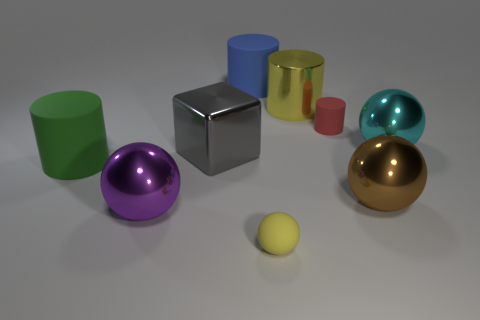There is a object that is the same color as the metal cylinder; what material is it?
Ensure brevity in your answer.  Rubber. Are there fewer purple metal objects that are behind the blue cylinder than shiny objects on the right side of the large gray metallic cube?
Give a very brief answer. Yes. What number of red cylinders are there?
Ensure brevity in your answer.  1. What is the color of the metallic sphere on the left side of the small yellow matte sphere?
Give a very brief answer. Purple. What size is the matte ball?
Your answer should be compact. Small. There is a tiny sphere; is its color the same as the large cylinder to the right of the yellow ball?
Ensure brevity in your answer.  Yes. The large rubber cylinder right of the rubber cylinder to the left of the purple metal thing is what color?
Offer a very short reply. Blue. There is a thing that is in front of the large purple metallic sphere; is it the same shape as the brown thing?
Provide a succinct answer. Yes. What number of large things are both in front of the big green rubber cylinder and to the right of the big blue thing?
Ensure brevity in your answer.  1. There is a tiny rubber thing that is behind the rubber cylinder on the left side of the large sphere to the left of the rubber ball; what color is it?
Your response must be concise. Red. 